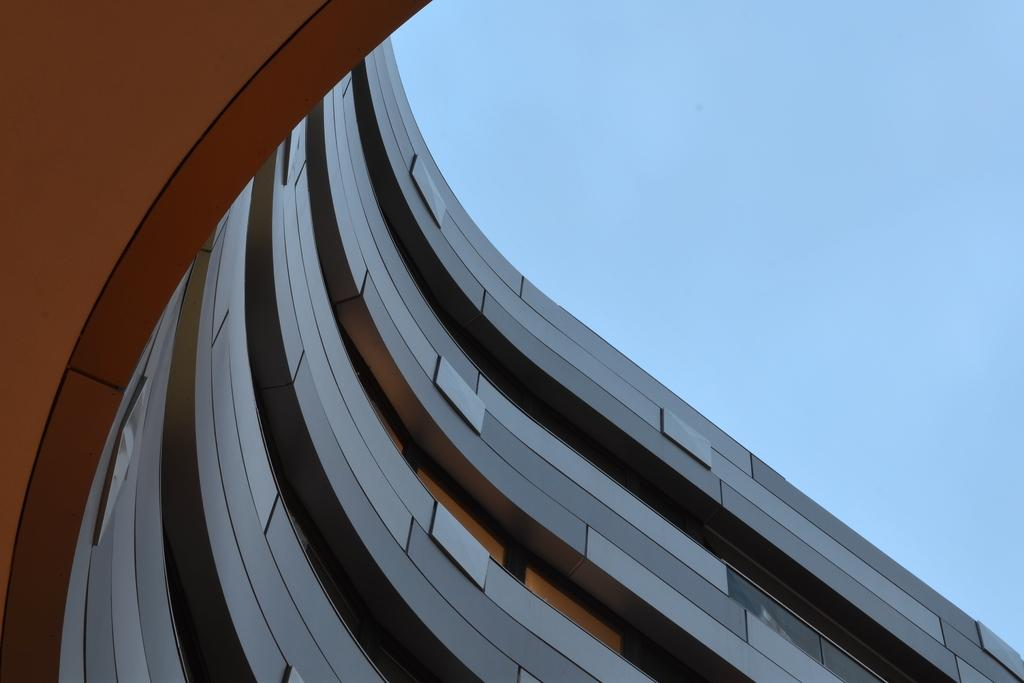What type of structure is shown in the image? The image depicts a four-story architectural building. What can be seen in the background of the image? The sky is visible in the image. What type of soap is being used to clean the windows of the building in the image? There is no soap or window cleaning activity depicted in the image. How many wrens can be seen perched on the building in the image? There are no wrens present in the image. 